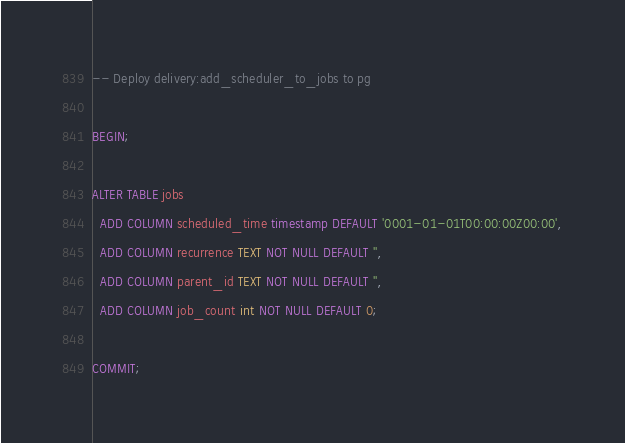<code> <loc_0><loc_0><loc_500><loc_500><_SQL_>-- Deploy delivery:add_scheduler_to_jobs to pg

BEGIN;

ALTER TABLE jobs
  ADD COLUMN scheduled_time timestamp DEFAULT '0001-01-01T00:00:00Z00:00',
  ADD COLUMN recurrence TEXT NOT NULL DEFAULT '',
  ADD COLUMN parent_id TEXT NOT NULL DEFAULT '',
  ADD COLUMN job_count int NOT NULL DEFAULT 0;

COMMIT;
</code> 